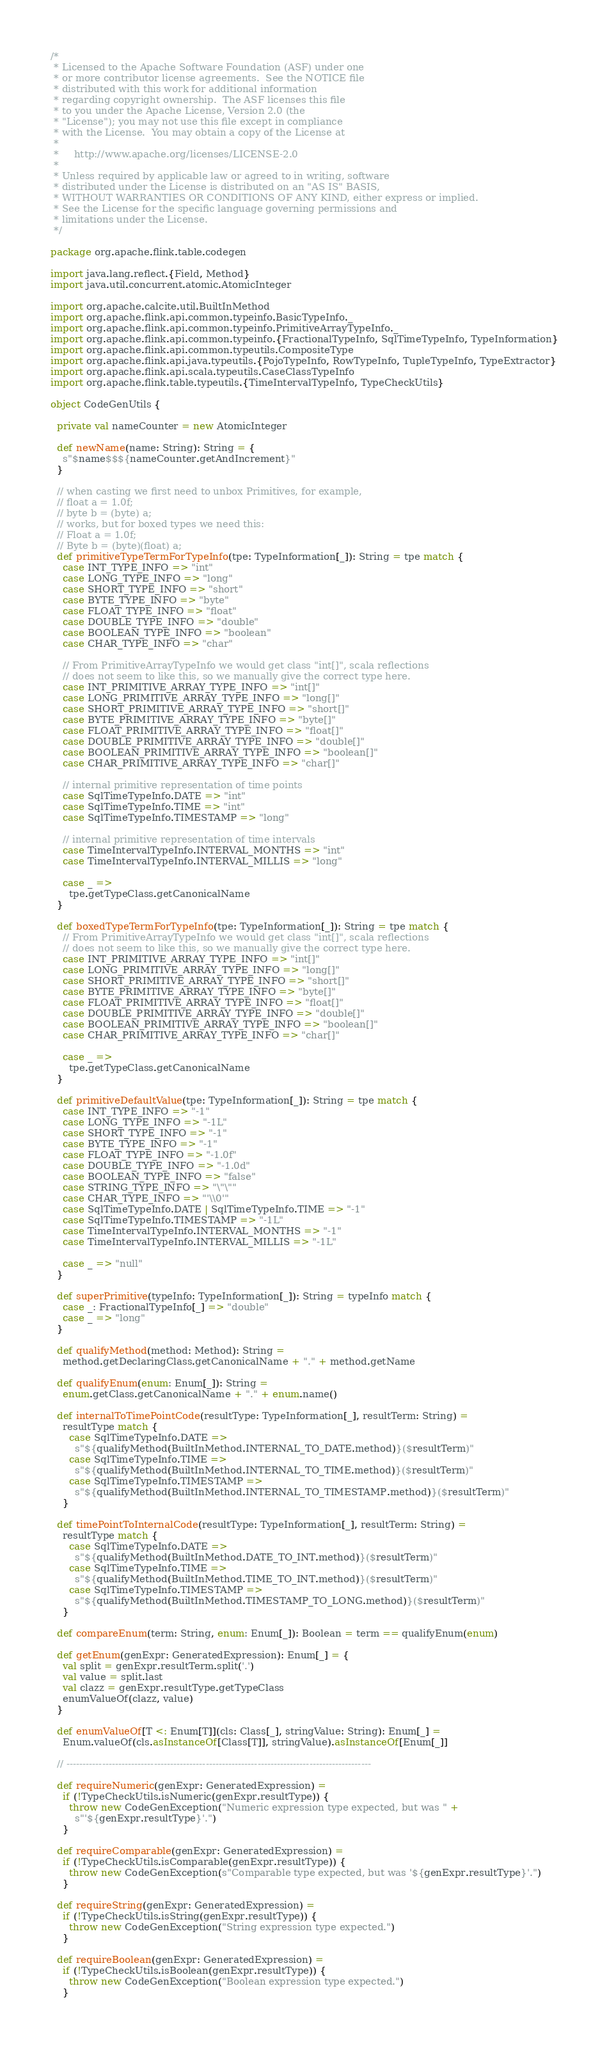Convert code to text. <code><loc_0><loc_0><loc_500><loc_500><_Scala_>/*
 * Licensed to the Apache Software Foundation (ASF) under one
 * or more contributor license agreements.  See the NOTICE file
 * distributed with this work for additional information
 * regarding copyright ownership.  The ASF licenses this file
 * to you under the Apache License, Version 2.0 (the
 * "License"); you may not use this file except in compliance
 * with the License.  You may obtain a copy of the License at
 *
 *     http://www.apache.org/licenses/LICENSE-2.0
 *
 * Unless required by applicable law or agreed to in writing, software
 * distributed under the License is distributed on an "AS IS" BASIS,
 * WITHOUT WARRANTIES OR CONDITIONS OF ANY KIND, either express or implied.
 * See the License for the specific language governing permissions and
 * limitations under the License.
 */

package org.apache.flink.table.codegen

import java.lang.reflect.{Field, Method}
import java.util.concurrent.atomic.AtomicInteger

import org.apache.calcite.util.BuiltInMethod
import org.apache.flink.api.common.typeinfo.BasicTypeInfo._
import org.apache.flink.api.common.typeinfo.PrimitiveArrayTypeInfo._
import org.apache.flink.api.common.typeinfo.{FractionalTypeInfo, SqlTimeTypeInfo, TypeInformation}
import org.apache.flink.api.common.typeutils.CompositeType
import org.apache.flink.api.java.typeutils.{PojoTypeInfo, RowTypeInfo, TupleTypeInfo, TypeExtractor}
import org.apache.flink.api.scala.typeutils.CaseClassTypeInfo
import org.apache.flink.table.typeutils.{TimeIntervalTypeInfo, TypeCheckUtils}

object CodeGenUtils {

  private val nameCounter = new AtomicInteger

  def newName(name: String): String = {
    s"$name$$${nameCounter.getAndIncrement}"
  }

  // when casting we first need to unbox Primitives, for example,
  // float a = 1.0f;
  // byte b = (byte) a;
  // works, but for boxed types we need this:
  // Float a = 1.0f;
  // Byte b = (byte)(float) a;
  def primitiveTypeTermForTypeInfo(tpe: TypeInformation[_]): String = tpe match {
    case INT_TYPE_INFO => "int"
    case LONG_TYPE_INFO => "long"
    case SHORT_TYPE_INFO => "short"
    case BYTE_TYPE_INFO => "byte"
    case FLOAT_TYPE_INFO => "float"
    case DOUBLE_TYPE_INFO => "double"
    case BOOLEAN_TYPE_INFO => "boolean"
    case CHAR_TYPE_INFO => "char"

    // From PrimitiveArrayTypeInfo we would get class "int[]", scala reflections
    // does not seem to like this, so we manually give the correct type here.
    case INT_PRIMITIVE_ARRAY_TYPE_INFO => "int[]"
    case LONG_PRIMITIVE_ARRAY_TYPE_INFO => "long[]"
    case SHORT_PRIMITIVE_ARRAY_TYPE_INFO => "short[]"
    case BYTE_PRIMITIVE_ARRAY_TYPE_INFO => "byte[]"
    case FLOAT_PRIMITIVE_ARRAY_TYPE_INFO => "float[]"
    case DOUBLE_PRIMITIVE_ARRAY_TYPE_INFO => "double[]"
    case BOOLEAN_PRIMITIVE_ARRAY_TYPE_INFO => "boolean[]"
    case CHAR_PRIMITIVE_ARRAY_TYPE_INFO => "char[]"

    // internal primitive representation of time points
    case SqlTimeTypeInfo.DATE => "int"
    case SqlTimeTypeInfo.TIME => "int"
    case SqlTimeTypeInfo.TIMESTAMP => "long"

    // internal primitive representation of time intervals
    case TimeIntervalTypeInfo.INTERVAL_MONTHS => "int"
    case TimeIntervalTypeInfo.INTERVAL_MILLIS => "long"

    case _ =>
      tpe.getTypeClass.getCanonicalName
  }

  def boxedTypeTermForTypeInfo(tpe: TypeInformation[_]): String = tpe match {
    // From PrimitiveArrayTypeInfo we would get class "int[]", scala reflections
    // does not seem to like this, so we manually give the correct type here.
    case INT_PRIMITIVE_ARRAY_TYPE_INFO => "int[]"
    case LONG_PRIMITIVE_ARRAY_TYPE_INFO => "long[]"
    case SHORT_PRIMITIVE_ARRAY_TYPE_INFO => "short[]"
    case BYTE_PRIMITIVE_ARRAY_TYPE_INFO => "byte[]"
    case FLOAT_PRIMITIVE_ARRAY_TYPE_INFO => "float[]"
    case DOUBLE_PRIMITIVE_ARRAY_TYPE_INFO => "double[]"
    case BOOLEAN_PRIMITIVE_ARRAY_TYPE_INFO => "boolean[]"
    case CHAR_PRIMITIVE_ARRAY_TYPE_INFO => "char[]"

    case _ =>
      tpe.getTypeClass.getCanonicalName
  }

  def primitiveDefaultValue(tpe: TypeInformation[_]): String = tpe match {
    case INT_TYPE_INFO => "-1"
    case LONG_TYPE_INFO => "-1L"
    case SHORT_TYPE_INFO => "-1"
    case BYTE_TYPE_INFO => "-1"
    case FLOAT_TYPE_INFO => "-1.0f"
    case DOUBLE_TYPE_INFO => "-1.0d"
    case BOOLEAN_TYPE_INFO => "false"
    case STRING_TYPE_INFO => "\"\""
    case CHAR_TYPE_INFO => "'\\0'"
    case SqlTimeTypeInfo.DATE | SqlTimeTypeInfo.TIME => "-1"
    case SqlTimeTypeInfo.TIMESTAMP => "-1L"
    case TimeIntervalTypeInfo.INTERVAL_MONTHS => "-1"
    case TimeIntervalTypeInfo.INTERVAL_MILLIS => "-1L"

    case _ => "null"
  }

  def superPrimitive(typeInfo: TypeInformation[_]): String = typeInfo match {
    case _: FractionalTypeInfo[_] => "double"
    case _ => "long"
  }

  def qualifyMethod(method: Method): String =
    method.getDeclaringClass.getCanonicalName + "." + method.getName

  def qualifyEnum(enum: Enum[_]): String =
    enum.getClass.getCanonicalName + "." + enum.name()

  def internalToTimePointCode(resultType: TypeInformation[_], resultTerm: String) =
    resultType match {
      case SqlTimeTypeInfo.DATE =>
        s"${qualifyMethod(BuiltInMethod.INTERNAL_TO_DATE.method)}($resultTerm)"
      case SqlTimeTypeInfo.TIME =>
        s"${qualifyMethod(BuiltInMethod.INTERNAL_TO_TIME.method)}($resultTerm)"
      case SqlTimeTypeInfo.TIMESTAMP =>
        s"${qualifyMethod(BuiltInMethod.INTERNAL_TO_TIMESTAMP.method)}($resultTerm)"
    }

  def timePointToInternalCode(resultType: TypeInformation[_], resultTerm: String) =
    resultType match {
      case SqlTimeTypeInfo.DATE =>
        s"${qualifyMethod(BuiltInMethod.DATE_TO_INT.method)}($resultTerm)"
      case SqlTimeTypeInfo.TIME =>
        s"${qualifyMethod(BuiltInMethod.TIME_TO_INT.method)}($resultTerm)"
      case SqlTimeTypeInfo.TIMESTAMP =>
        s"${qualifyMethod(BuiltInMethod.TIMESTAMP_TO_LONG.method)}($resultTerm)"
    }

  def compareEnum(term: String, enum: Enum[_]): Boolean = term == qualifyEnum(enum)

  def getEnum(genExpr: GeneratedExpression): Enum[_] = {
    val split = genExpr.resultTerm.split('.')
    val value = split.last
    val clazz = genExpr.resultType.getTypeClass
    enumValueOf(clazz, value)
  }

  def enumValueOf[T <: Enum[T]](cls: Class[_], stringValue: String): Enum[_] =
    Enum.valueOf(cls.asInstanceOf[Class[T]], stringValue).asInstanceOf[Enum[_]]

  // ----------------------------------------------------------------------------------------------

  def requireNumeric(genExpr: GeneratedExpression) =
    if (!TypeCheckUtils.isNumeric(genExpr.resultType)) {
      throw new CodeGenException("Numeric expression type expected, but was " +
        s"'${genExpr.resultType}'.")
    }

  def requireComparable(genExpr: GeneratedExpression) =
    if (!TypeCheckUtils.isComparable(genExpr.resultType)) {
      throw new CodeGenException(s"Comparable type expected, but was '${genExpr.resultType}'.")
    }

  def requireString(genExpr: GeneratedExpression) =
    if (!TypeCheckUtils.isString(genExpr.resultType)) {
      throw new CodeGenException("String expression type expected.")
    }

  def requireBoolean(genExpr: GeneratedExpression) =
    if (!TypeCheckUtils.isBoolean(genExpr.resultType)) {
      throw new CodeGenException("Boolean expression type expected.")
    }
</code> 